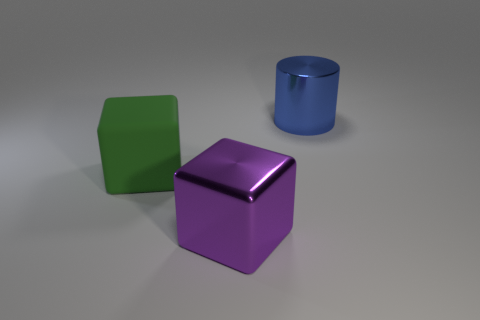Are any big objects visible?
Provide a succinct answer. Yes. Are there more large cubes that are in front of the green object than yellow rubber spheres?
Your response must be concise. Yes. What is the shape of the big rubber object?
Give a very brief answer. Cube. Is the purple metallic thing the same shape as the large blue thing?
Provide a succinct answer. No. Is there any other thing that is the same shape as the big green matte thing?
Offer a terse response. Yes. Is the material of the block that is in front of the green rubber object the same as the large blue object?
Keep it short and to the point. Yes. There is a large thing that is both on the right side of the big green cube and behind the purple shiny block; what shape is it?
Provide a succinct answer. Cylinder. There is a object that is in front of the rubber thing; is there a big blue cylinder to the right of it?
Your response must be concise. Yes. What number of other objects are the same material as the blue object?
Give a very brief answer. 1. Is the shape of the object in front of the green cube the same as the object that is on the left side of the large purple metal cube?
Make the answer very short. Yes. 